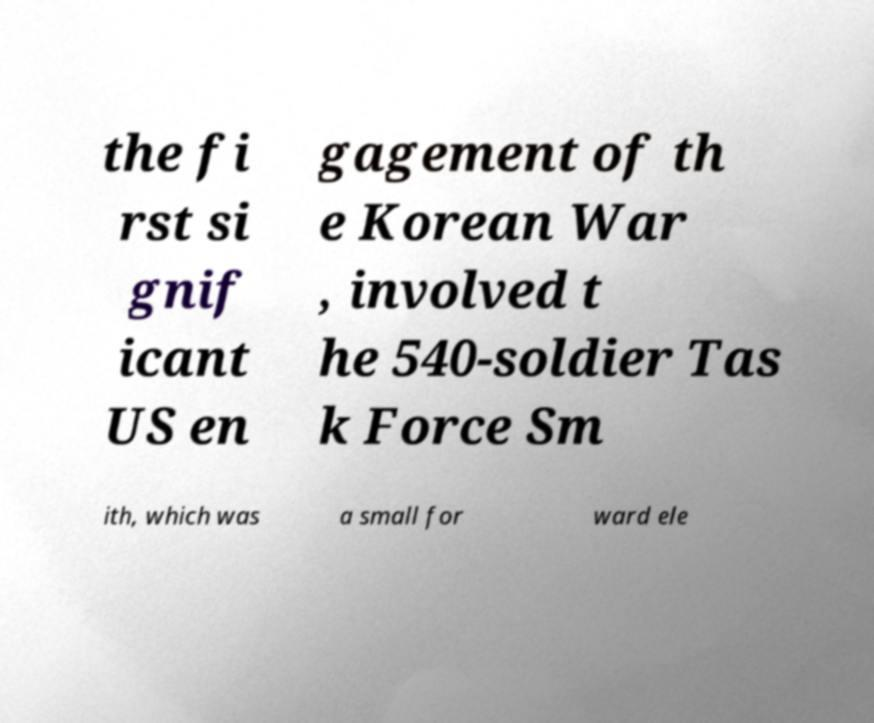I need the written content from this picture converted into text. Can you do that? the fi rst si gnif icant US en gagement of th e Korean War , involved t he 540-soldier Tas k Force Sm ith, which was a small for ward ele 